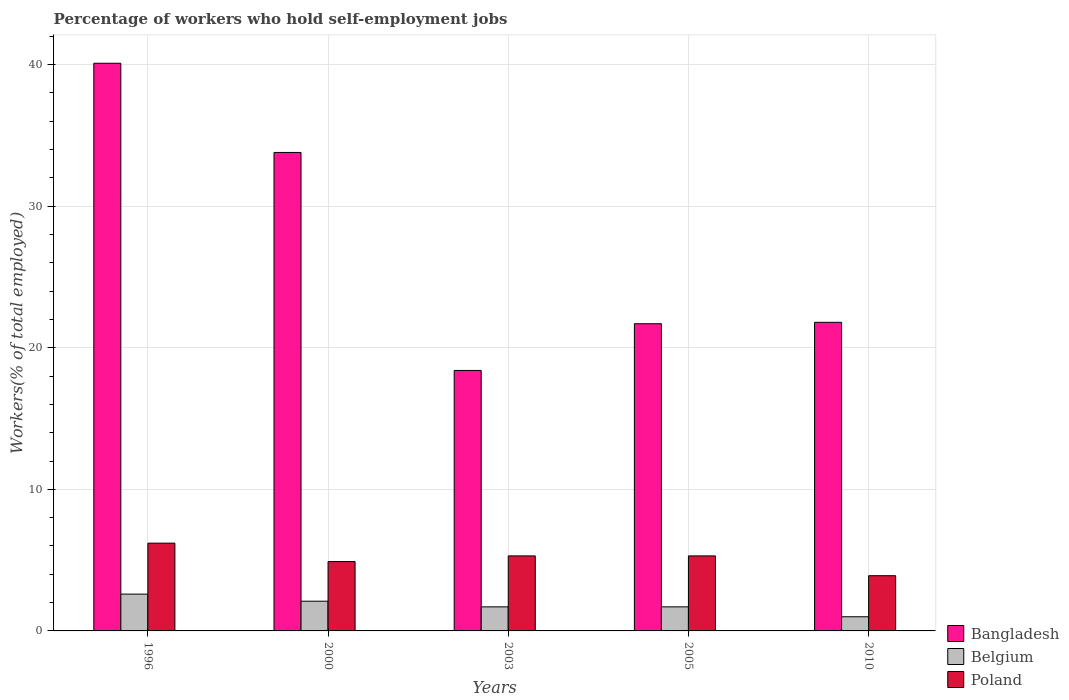How many different coloured bars are there?
Give a very brief answer. 3. How many groups of bars are there?
Give a very brief answer. 5. How many bars are there on the 5th tick from the left?
Give a very brief answer. 3. How many bars are there on the 4th tick from the right?
Make the answer very short. 3. What is the label of the 5th group of bars from the left?
Provide a succinct answer. 2010. In how many cases, is the number of bars for a given year not equal to the number of legend labels?
Make the answer very short. 0. What is the percentage of self-employed workers in Belgium in 1996?
Provide a succinct answer. 2.6. Across all years, what is the maximum percentage of self-employed workers in Belgium?
Offer a very short reply. 2.6. Across all years, what is the minimum percentage of self-employed workers in Bangladesh?
Offer a terse response. 18.4. In which year was the percentage of self-employed workers in Bangladesh maximum?
Ensure brevity in your answer.  1996. What is the total percentage of self-employed workers in Belgium in the graph?
Provide a succinct answer. 9.1. What is the difference between the percentage of self-employed workers in Poland in 1996 and that in 2000?
Keep it short and to the point. 1.3. What is the difference between the percentage of self-employed workers in Poland in 2010 and the percentage of self-employed workers in Bangladesh in 2005?
Provide a short and direct response. -17.8. What is the average percentage of self-employed workers in Poland per year?
Make the answer very short. 5.12. In the year 2010, what is the difference between the percentage of self-employed workers in Bangladesh and percentage of self-employed workers in Belgium?
Provide a succinct answer. 20.8. What is the ratio of the percentage of self-employed workers in Bangladesh in 1996 to that in 2005?
Offer a very short reply. 1.85. Is the percentage of self-employed workers in Belgium in 1996 less than that in 2010?
Keep it short and to the point. No. What is the difference between the highest and the second highest percentage of self-employed workers in Belgium?
Your answer should be very brief. 0.5. What is the difference between the highest and the lowest percentage of self-employed workers in Belgium?
Your answer should be compact. 1.6. In how many years, is the percentage of self-employed workers in Bangladesh greater than the average percentage of self-employed workers in Bangladesh taken over all years?
Provide a short and direct response. 2. Is it the case that in every year, the sum of the percentage of self-employed workers in Poland and percentage of self-employed workers in Bangladesh is greater than the percentage of self-employed workers in Belgium?
Offer a terse response. Yes. What is the difference between two consecutive major ticks on the Y-axis?
Make the answer very short. 10. Are the values on the major ticks of Y-axis written in scientific E-notation?
Provide a succinct answer. No. Where does the legend appear in the graph?
Your answer should be very brief. Bottom right. What is the title of the graph?
Your answer should be very brief. Percentage of workers who hold self-employment jobs. What is the label or title of the Y-axis?
Give a very brief answer. Workers(% of total employed). What is the Workers(% of total employed) of Bangladesh in 1996?
Give a very brief answer. 40.1. What is the Workers(% of total employed) of Belgium in 1996?
Make the answer very short. 2.6. What is the Workers(% of total employed) in Poland in 1996?
Give a very brief answer. 6.2. What is the Workers(% of total employed) of Bangladesh in 2000?
Provide a short and direct response. 33.8. What is the Workers(% of total employed) of Belgium in 2000?
Your answer should be very brief. 2.1. What is the Workers(% of total employed) of Poland in 2000?
Provide a succinct answer. 4.9. What is the Workers(% of total employed) in Bangladesh in 2003?
Give a very brief answer. 18.4. What is the Workers(% of total employed) in Belgium in 2003?
Keep it short and to the point. 1.7. What is the Workers(% of total employed) of Poland in 2003?
Offer a very short reply. 5.3. What is the Workers(% of total employed) of Bangladesh in 2005?
Your answer should be very brief. 21.7. What is the Workers(% of total employed) of Belgium in 2005?
Make the answer very short. 1.7. What is the Workers(% of total employed) of Poland in 2005?
Provide a short and direct response. 5.3. What is the Workers(% of total employed) in Bangladesh in 2010?
Provide a short and direct response. 21.8. What is the Workers(% of total employed) in Poland in 2010?
Make the answer very short. 3.9. Across all years, what is the maximum Workers(% of total employed) of Bangladesh?
Give a very brief answer. 40.1. Across all years, what is the maximum Workers(% of total employed) of Belgium?
Your answer should be compact. 2.6. Across all years, what is the maximum Workers(% of total employed) of Poland?
Your answer should be compact. 6.2. Across all years, what is the minimum Workers(% of total employed) in Bangladesh?
Make the answer very short. 18.4. Across all years, what is the minimum Workers(% of total employed) of Belgium?
Offer a terse response. 1. Across all years, what is the minimum Workers(% of total employed) in Poland?
Offer a terse response. 3.9. What is the total Workers(% of total employed) in Bangladesh in the graph?
Make the answer very short. 135.8. What is the total Workers(% of total employed) of Belgium in the graph?
Your response must be concise. 9.1. What is the total Workers(% of total employed) in Poland in the graph?
Your answer should be very brief. 25.6. What is the difference between the Workers(% of total employed) of Bangladesh in 1996 and that in 2003?
Provide a short and direct response. 21.7. What is the difference between the Workers(% of total employed) in Belgium in 1996 and that in 2003?
Your answer should be very brief. 0.9. What is the difference between the Workers(% of total employed) of Poland in 1996 and that in 2003?
Your answer should be very brief. 0.9. What is the difference between the Workers(% of total employed) in Bangladesh in 1996 and that in 2005?
Provide a succinct answer. 18.4. What is the difference between the Workers(% of total employed) of Belgium in 1996 and that in 2005?
Keep it short and to the point. 0.9. What is the difference between the Workers(% of total employed) in Bangladesh in 1996 and that in 2010?
Your answer should be compact. 18.3. What is the difference between the Workers(% of total employed) in Belgium in 1996 and that in 2010?
Provide a short and direct response. 1.6. What is the difference between the Workers(% of total employed) in Belgium in 2000 and that in 2003?
Your response must be concise. 0.4. What is the difference between the Workers(% of total employed) in Poland in 2000 and that in 2003?
Give a very brief answer. -0.4. What is the difference between the Workers(% of total employed) of Belgium in 2000 and that in 2005?
Your answer should be very brief. 0.4. What is the difference between the Workers(% of total employed) in Bangladesh in 2000 and that in 2010?
Provide a succinct answer. 12. What is the difference between the Workers(% of total employed) of Belgium in 2000 and that in 2010?
Make the answer very short. 1.1. What is the difference between the Workers(% of total employed) of Belgium in 2003 and that in 2005?
Ensure brevity in your answer.  0. What is the difference between the Workers(% of total employed) of Poland in 2003 and that in 2005?
Ensure brevity in your answer.  0. What is the difference between the Workers(% of total employed) of Bangladesh in 2003 and that in 2010?
Your response must be concise. -3.4. What is the difference between the Workers(% of total employed) in Poland in 2005 and that in 2010?
Give a very brief answer. 1.4. What is the difference between the Workers(% of total employed) of Bangladesh in 1996 and the Workers(% of total employed) of Poland in 2000?
Make the answer very short. 35.2. What is the difference between the Workers(% of total employed) of Bangladesh in 1996 and the Workers(% of total employed) of Belgium in 2003?
Offer a terse response. 38.4. What is the difference between the Workers(% of total employed) in Bangladesh in 1996 and the Workers(% of total employed) in Poland in 2003?
Your response must be concise. 34.8. What is the difference between the Workers(% of total employed) in Belgium in 1996 and the Workers(% of total employed) in Poland in 2003?
Your answer should be very brief. -2.7. What is the difference between the Workers(% of total employed) in Bangladesh in 1996 and the Workers(% of total employed) in Belgium in 2005?
Give a very brief answer. 38.4. What is the difference between the Workers(% of total employed) of Bangladesh in 1996 and the Workers(% of total employed) of Poland in 2005?
Your answer should be compact. 34.8. What is the difference between the Workers(% of total employed) of Bangladesh in 1996 and the Workers(% of total employed) of Belgium in 2010?
Provide a succinct answer. 39.1. What is the difference between the Workers(% of total employed) of Bangladesh in 1996 and the Workers(% of total employed) of Poland in 2010?
Make the answer very short. 36.2. What is the difference between the Workers(% of total employed) of Bangladesh in 2000 and the Workers(% of total employed) of Belgium in 2003?
Your answer should be compact. 32.1. What is the difference between the Workers(% of total employed) of Bangladesh in 2000 and the Workers(% of total employed) of Poland in 2003?
Provide a short and direct response. 28.5. What is the difference between the Workers(% of total employed) in Bangladesh in 2000 and the Workers(% of total employed) in Belgium in 2005?
Keep it short and to the point. 32.1. What is the difference between the Workers(% of total employed) of Bangladesh in 2000 and the Workers(% of total employed) of Belgium in 2010?
Keep it short and to the point. 32.8. What is the difference between the Workers(% of total employed) of Bangladesh in 2000 and the Workers(% of total employed) of Poland in 2010?
Your response must be concise. 29.9. What is the difference between the Workers(% of total employed) of Belgium in 2000 and the Workers(% of total employed) of Poland in 2010?
Ensure brevity in your answer.  -1.8. What is the difference between the Workers(% of total employed) of Bangladesh in 2003 and the Workers(% of total employed) of Belgium in 2005?
Your answer should be compact. 16.7. What is the difference between the Workers(% of total employed) of Bangladesh in 2003 and the Workers(% of total employed) of Belgium in 2010?
Provide a short and direct response. 17.4. What is the difference between the Workers(% of total employed) in Bangladesh in 2003 and the Workers(% of total employed) in Poland in 2010?
Make the answer very short. 14.5. What is the difference between the Workers(% of total employed) in Belgium in 2003 and the Workers(% of total employed) in Poland in 2010?
Offer a terse response. -2.2. What is the difference between the Workers(% of total employed) of Bangladesh in 2005 and the Workers(% of total employed) of Belgium in 2010?
Offer a terse response. 20.7. What is the difference between the Workers(% of total employed) in Bangladesh in 2005 and the Workers(% of total employed) in Poland in 2010?
Keep it short and to the point. 17.8. What is the difference between the Workers(% of total employed) in Belgium in 2005 and the Workers(% of total employed) in Poland in 2010?
Make the answer very short. -2.2. What is the average Workers(% of total employed) in Bangladesh per year?
Your answer should be very brief. 27.16. What is the average Workers(% of total employed) in Belgium per year?
Provide a succinct answer. 1.82. What is the average Workers(% of total employed) in Poland per year?
Your response must be concise. 5.12. In the year 1996, what is the difference between the Workers(% of total employed) in Bangladesh and Workers(% of total employed) in Belgium?
Provide a short and direct response. 37.5. In the year 1996, what is the difference between the Workers(% of total employed) in Bangladesh and Workers(% of total employed) in Poland?
Ensure brevity in your answer.  33.9. In the year 2000, what is the difference between the Workers(% of total employed) of Bangladesh and Workers(% of total employed) of Belgium?
Offer a terse response. 31.7. In the year 2000, what is the difference between the Workers(% of total employed) of Bangladesh and Workers(% of total employed) of Poland?
Offer a terse response. 28.9. In the year 2000, what is the difference between the Workers(% of total employed) in Belgium and Workers(% of total employed) in Poland?
Keep it short and to the point. -2.8. In the year 2003, what is the difference between the Workers(% of total employed) in Bangladesh and Workers(% of total employed) in Belgium?
Your answer should be very brief. 16.7. In the year 2003, what is the difference between the Workers(% of total employed) in Bangladesh and Workers(% of total employed) in Poland?
Your answer should be compact. 13.1. In the year 2003, what is the difference between the Workers(% of total employed) in Belgium and Workers(% of total employed) in Poland?
Your answer should be compact. -3.6. In the year 2010, what is the difference between the Workers(% of total employed) of Bangladesh and Workers(% of total employed) of Belgium?
Your response must be concise. 20.8. In the year 2010, what is the difference between the Workers(% of total employed) in Bangladesh and Workers(% of total employed) in Poland?
Your response must be concise. 17.9. What is the ratio of the Workers(% of total employed) in Bangladesh in 1996 to that in 2000?
Offer a very short reply. 1.19. What is the ratio of the Workers(% of total employed) in Belgium in 1996 to that in 2000?
Give a very brief answer. 1.24. What is the ratio of the Workers(% of total employed) in Poland in 1996 to that in 2000?
Offer a terse response. 1.27. What is the ratio of the Workers(% of total employed) in Bangladesh in 1996 to that in 2003?
Offer a terse response. 2.18. What is the ratio of the Workers(% of total employed) in Belgium in 1996 to that in 2003?
Keep it short and to the point. 1.53. What is the ratio of the Workers(% of total employed) of Poland in 1996 to that in 2003?
Keep it short and to the point. 1.17. What is the ratio of the Workers(% of total employed) of Bangladesh in 1996 to that in 2005?
Provide a short and direct response. 1.85. What is the ratio of the Workers(% of total employed) of Belgium in 1996 to that in 2005?
Your answer should be compact. 1.53. What is the ratio of the Workers(% of total employed) of Poland in 1996 to that in 2005?
Offer a very short reply. 1.17. What is the ratio of the Workers(% of total employed) in Bangladesh in 1996 to that in 2010?
Your response must be concise. 1.84. What is the ratio of the Workers(% of total employed) of Poland in 1996 to that in 2010?
Provide a short and direct response. 1.59. What is the ratio of the Workers(% of total employed) in Bangladesh in 2000 to that in 2003?
Keep it short and to the point. 1.84. What is the ratio of the Workers(% of total employed) in Belgium in 2000 to that in 2003?
Make the answer very short. 1.24. What is the ratio of the Workers(% of total employed) in Poland in 2000 to that in 2003?
Ensure brevity in your answer.  0.92. What is the ratio of the Workers(% of total employed) of Bangladesh in 2000 to that in 2005?
Your answer should be compact. 1.56. What is the ratio of the Workers(% of total employed) of Belgium in 2000 to that in 2005?
Your answer should be compact. 1.24. What is the ratio of the Workers(% of total employed) in Poland in 2000 to that in 2005?
Give a very brief answer. 0.92. What is the ratio of the Workers(% of total employed) of Bangladesh in 2000 to that in 2010?
Provide a succinct answer. 1.55. What is the ratio of the Workers(% of total employed) of Belgium in 2000 to that in 2010?
Provide a short and direct response. 2.1. What is the ratio of the Workers(% of total employed) of Poland in 2000 to that in 2010?
Offer a very short reply. 1.26. What is the ratio of the Workers(% of total employed) of Bangladesh in 2003 to that in 2005?
Keep it short and to the point. 0.85. What is the ratio of the Workers(% of total employed) of Belgium in 2003 to that in 2005?
Provide a short and direct response. 1. What is the ratio of the Workers(% of total employed) in Poland in 2003 to that in 2005?
Provide a succinct answer. 1. What is the ratio of the Workers(% of total employed) in Bangladesh in 2003 to that in 2010?
Make the answer very short. 0.84. What is the ratio of the Workers(% of total employed) of Belgium in 2003 to that in 2010?
Offer a very short reply. 1.7. What is the ratio of the Workers(% of total employed) in Poland in 2003 to that in 2010?
Your answer should be very brief. 1.36. What is the ratio of the Workers(% of total employed) of Bangladesh in 2005 to that in 2010?
Provide a succinct answer. 1. What is the ratio of the Workers(% of total employed) in Poland in 2005 to that in 2010?
Give a very brief answer. 1.36. What is the difference between the highest and the lowest Workers(% of total employed) of Bangladesh?
Your answer should be very brief. 21.7. 